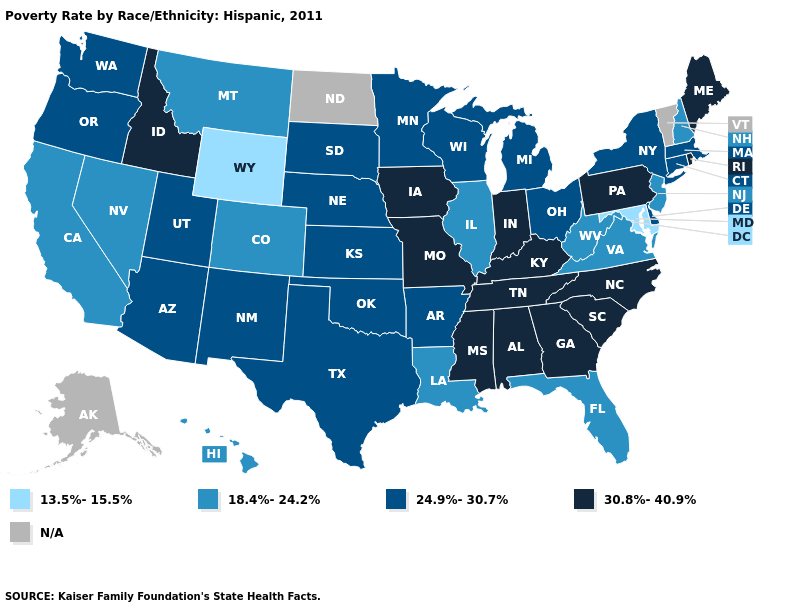What is the value of Kansas?
Answer briefly. 24.9%-30.7%. What is the value of South Dakota?
Quick response, please. 24.9%-30.7%. Is the legend a continuous bar?
Be succinct. No. What is the highest value in the MidWest ?
Answer briefly. 30.8%-40.9%. Name the states that have a value in the range N/A?
Write a very short answer. Alaska, North Dakota, Vermont. What is the value of Maryland?
Short answer required. 13.5%-15.5%. What is the highest value in the USA?
Write a very short answer. 30.8%-40.9%. Name the states that have a value in the range 18.4%-24.2%?
Answer briefly. California, Colorado, Florida, Hawaii, Illinois, Louisiana, Montana, Nevada, New Hampshire, New Jersey, Virginia, West Virginia. What is the lowest value in states that border West Virginia?
Short answer required. 13.5%-15.5%. What is the value of Utah?
Quick response, please. 24.9%-30.7%. Name the states that have a value in the range 30.8%-40.9%?
Short answer required. Alabama, Georgia, Idaho, Indiana, Iowa, Kentucky, Maine, Mississippi, Missouri, North Carolina, Pennsylvania, Rhode Island, South Carolina, Tennessee. What is the lowest value in the Northeast?
Quick response, please. 18.4%-24.2%. What is the value of Alaska?
Short answer required. N/A. Does the first symbol in the legend represent the smallest category?
Keep it brief. Yes. 